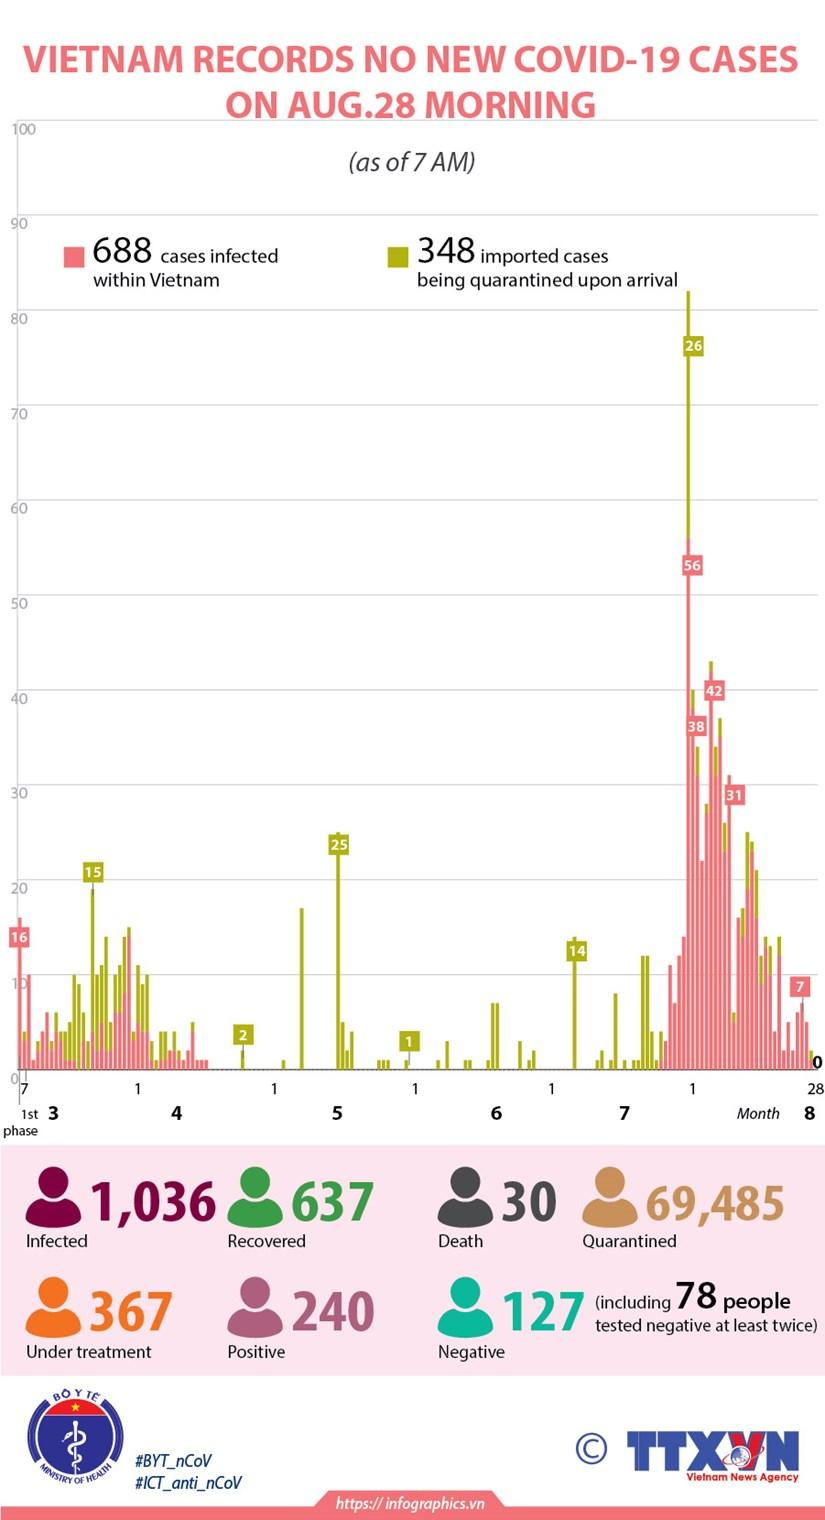List a handful of essential elements in this visual. Out of the total number of individuals affected by the disease, 637 individuals were able to recover and successfully come out of it. It is recommended that 69,485 individuals remain at home. Out of the 49 samples tested, 49 samples turned negative at the first time check. As of August 28th, approximately 240 test results have turned positive in Vietnam. As of February 21, 2023, there have been a total of 1,036 people infected with the COVID-19 virus in Vietnam. 